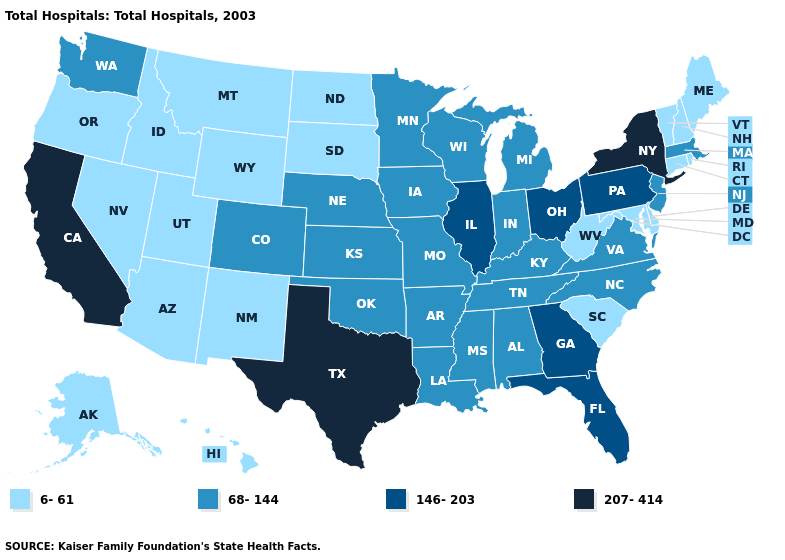What is the highest value in states that border Wyoming?
Concise answer only. 68-144. What is the lowest value in the West?
Quick response, please. 6-61. Does the first symbol in the legend represent the smallest category?
Short answer required. Yes. Name the states that have a value in the range 68-144?
Keep it brief. Alabama, Arkansas, Colorado, Indiana, Iowa, Kansas, Kentucky, Louisiana, Massachusetts, Michigan, Minnesota, Mississippi, Missouri, Nebraska, New Jersey, North Carolina, Oklahoma, Tennessee, Virginia, Washington, Wisconsin. Among the states that border Florida , does Alabama have the lowest value?
Quick response, please. Yes. Which states have the highest value in the USA?
Short answer required. California, New York, Texas. What is the value of Tennessee?
Write a very short answer. 68-144. Name the states that have a value in the range 68-144?
Answer briefly. Alabama, Arkansas, Colorado, Indiana, Iowa, Kansas, Kentucky, Louisiana, Massachusetts, Michigan, Minnesota, Mississippi, Missouri, Nebraska, New Jersey, North Carolina, Oklahoma, Tennessee, Virginia, Washington, Wisconsin. Name the states that have a value in the range 207-414?
Give a very brief answer. California, New York, Texas. Does Louisiana have the same value as Rhode Island?
Write a very short answer. No. What is the value of Connecticut?
Answer briefly. 6-61. What is the value of West Virginia?
Quick response, please. 6-61. What is the value of Florida?
Quick response, please. 146-203. What is the value of Rhode Island?
Keep it brief. 6-61. Name the states that have a value in the range 6-61?
Concise answer only. Alaska, Arizona, Connecticut, Delaware, Hawaii, Idaho, Maine, Maryland, Montana, Nevada, New Hampshire, New Mexico, North Dakota, Oregon, Rhode Island, South Carolina, South Dakota, Utah, Vermont, West Virginia, Wyoming. 